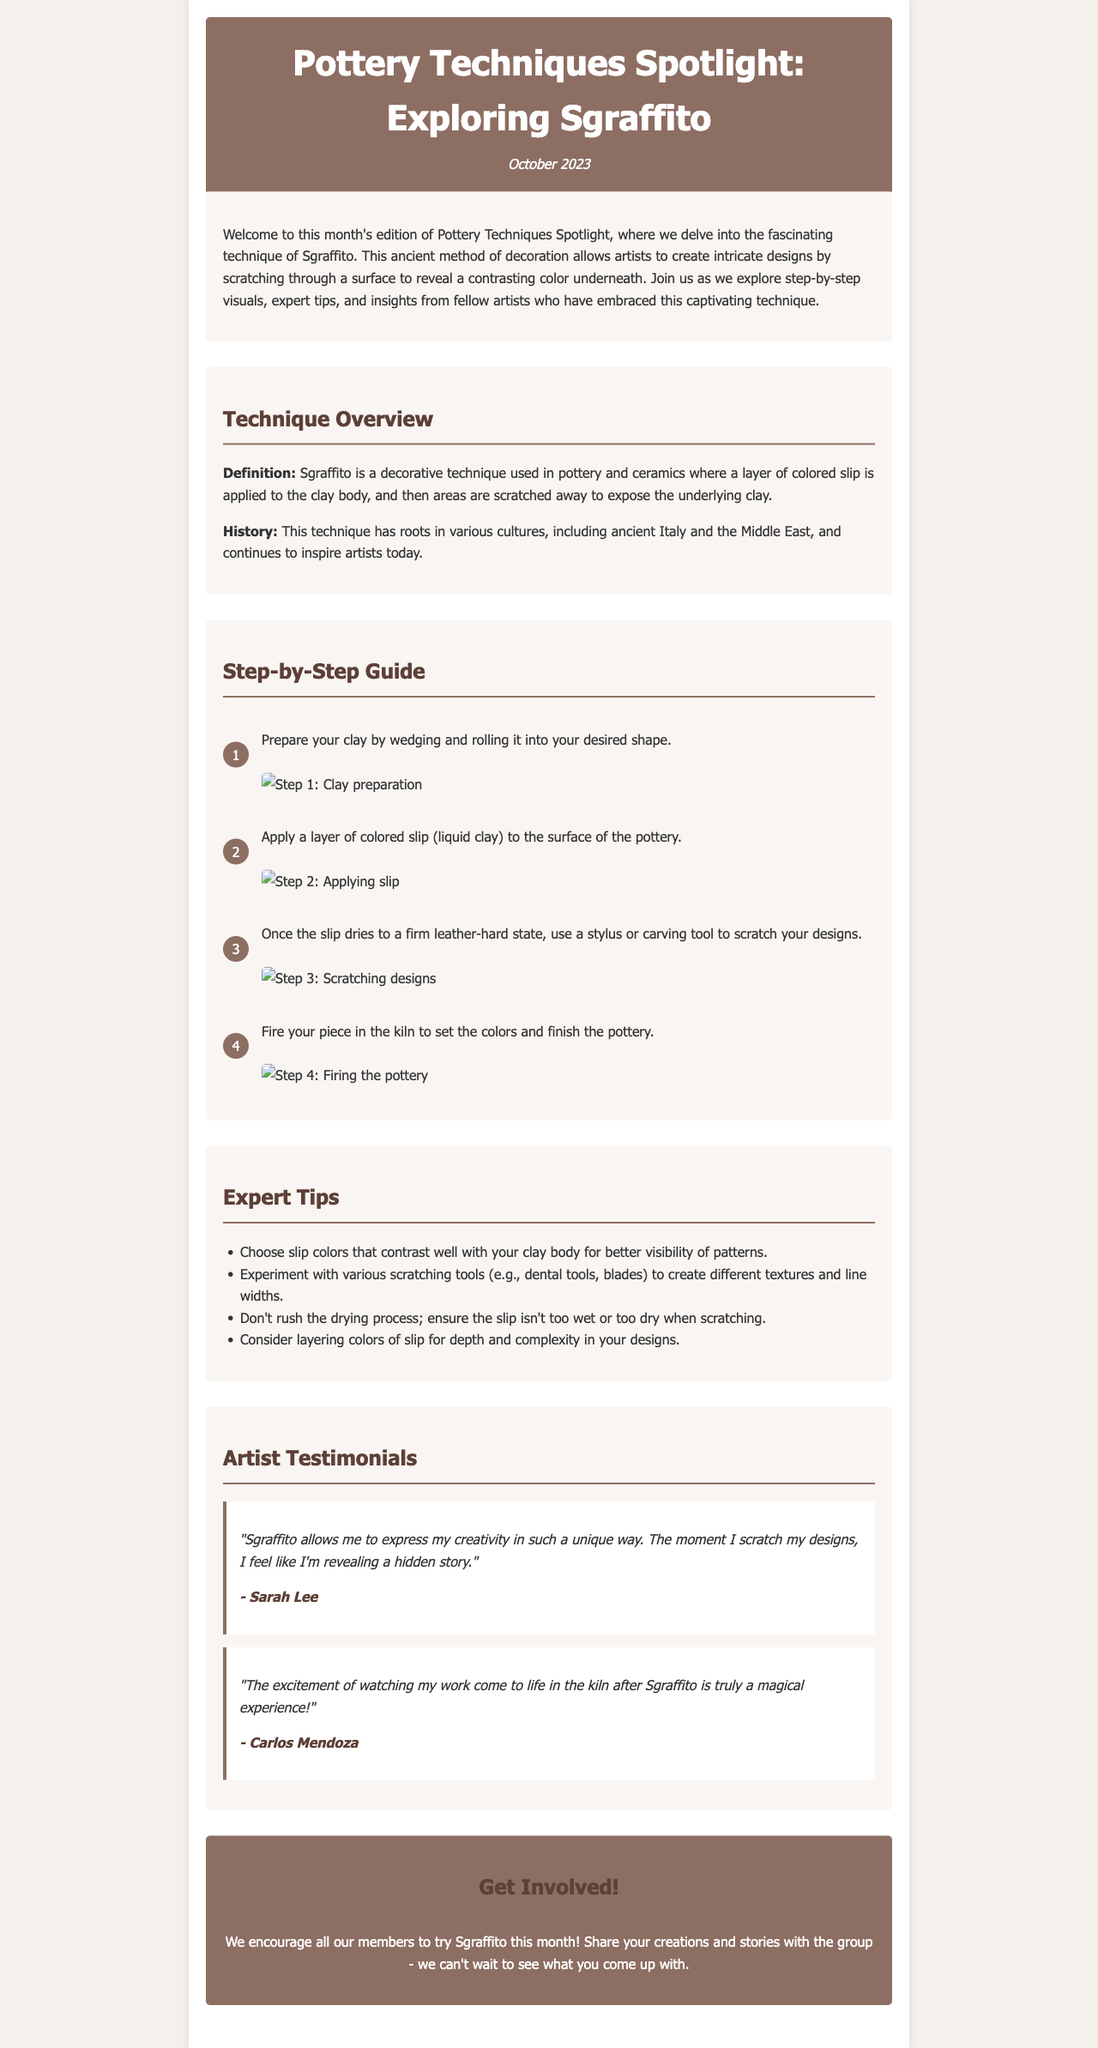What is the title of this newsletter? The title is presented prominently at the top of the document, which is "Pottery Techniques Spotlight: Exploring Sgraffito."
Answer: Pottery Techniques Spotlight: Exploring Sgraffito What is the issue month of this newsletter? The issue month is provided in the header, specifically listed as October 2023.
Answer: October 2023 What is the main decorative technique discussed in this issue? The document focuses on the technique of Sgraffito as outlined in the introduction and throughout the sections.
Answer: Sgraffito How many steps are there in the step-by-step guide? The step-by-step guide includes four numbered steps for the Sgraffito technique.
Answer: Four Who is the first artist to provide a testimonial? The first artist mentioned in the testimonials section is identified by their name, which is Sarah Lee.
Answer: Sarah Lee What should artists consider when selecting slip colors? The expert tips suggest choosing slip colors that contrast well with the clay body for visibility of patterns.
Answer: Contrast well In what state should the slip be when scratching designs? The document advises that the slip should be in a firm leather-hard state for scratching designs effectively.
Answer: Leather-hard What is a recommended tool for scratching in Sgraffito? The tips section mentions that various scratching tools can be used, including dental tools.
Answer: Dental tools What experience do artists describe regarding Sgraffito? Artist testimonials express the excitement of creation, notably the experience of watching work come to life in the kiln.
Answer: Magical experience 